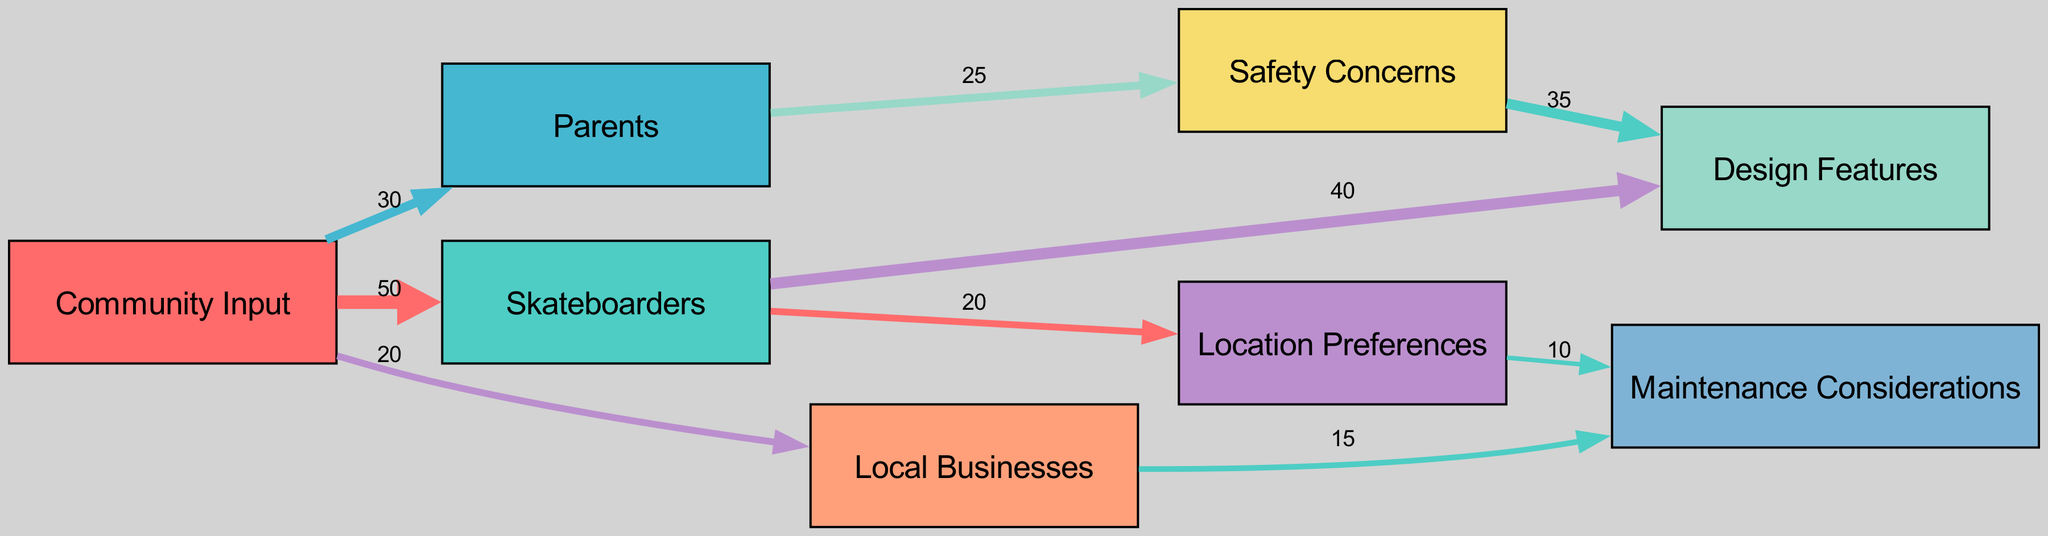What is the total number of nodes in the diagram? The diagram contains a total of 8 nodes, including "Community Input", "Skateboarders", "Parents", "Local Businesses", "Design Features", "Safety Concerns", "Location Preferences", and "Maintenance Considerations".
Answer: 8 How many links connect to the "Skateboarders" node? There are 3 links that connect to the "Skateboarders" node: one from "Community Input", one to "Design Features", and one to "Location Preferences".
Answer: 3 What value is represented by the link from "Parents" to "Safety Concerns"? The link from "Parents" to "Safety Concerns" has a value of 25, indicating that this represents the quantity of feedback from parents about safety issues related to the skate park.
Answer: 25 Which node has the highest value of outgoing links based on the "Skateboarders" connections? The "Skateboarders" node has the highest outgoing link value to "Design Features" with a value of 40, as most skateboarders are focusing their feedback on the design aspects of the skate park.
Answer: Design Features Which feature is most frequently mentioned related to concerns from "Parents"? "Safety Concerns" is the feature that is most frequently mentioned with a value of 25 based on the parent feedback, as it indicates their priority regarding the park's safety.
Answer: Safety Concerns What is the relationship between "Location Preferences" and "Maintenance Considerations"? The link from "Location Preferences" to "Maintenance Considerations" has a value of 10, suggesting that there are some considerations for maintenance based on the location chosen for the skate park.
Answer: 10 How much feedback did "Local Businesses" give regarding "Maintenance Considerations"? "Local Businesses" provided feedback related to "Maintenance Considerations" with a value of 15, suggesting some level of input regarding the upkeep of the skate park.
Answer: 15 Which group provided the least amount of input about the skate park design? "Local Businesses" provided the least amount of input, with a total value of 20 which is lower than both skateboarders and parents.
Answer: Local Businesses What is the total weight of feedback directed from "Community Input" to all groups? The total weight of feedback directed from "Community Input" is 100, calculated as 50 to Skateboarders, 30 to Parents, and 20 to Local Businesses.
Answer: 100 